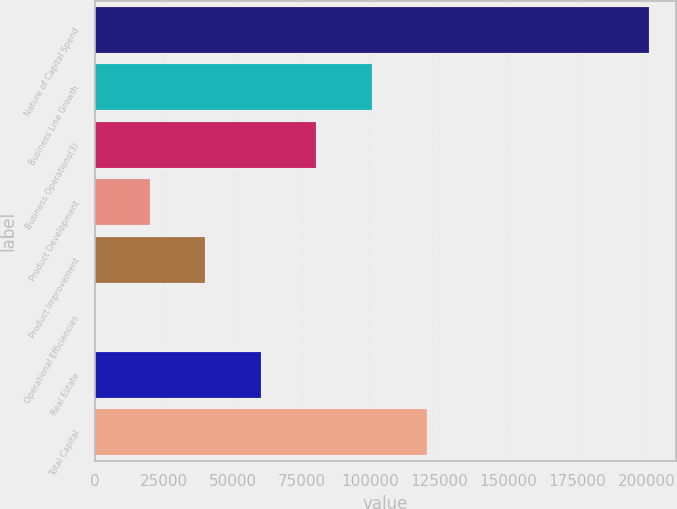Convert chart. <chart><loc_0><loc_0><loc_500><loc_500><bar_chart><fcel>Nature of Capital Spend<fcel>Business Line Growth<fcel>Business Operations(3)<fcel>Product Development<fcel>Product Improvement<fcel>Operational Efficiencies<fcel>Real Estate<fcel>Total Capital<nl><fcel>200912<fcel>100460<fcel>80370.2<fcel>20099.3<fcel>40189.6<fcel>9<fcel>60279.9<fcel>120551<nl></chart> 